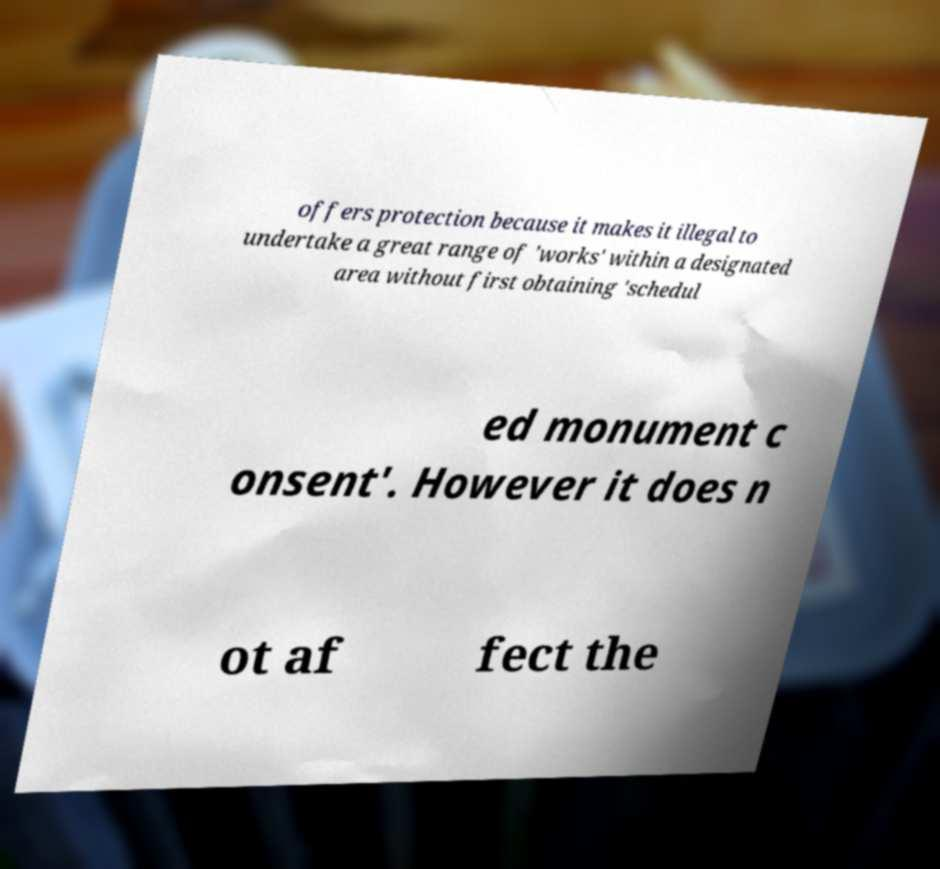Please read and relay the text visible in this image. What does it say? offers protection because it makes it illegal to undertake a great range of 'works' within a designated area without first obtaining 'schedul ed monument c onsent'. However it does n ot af fect the 